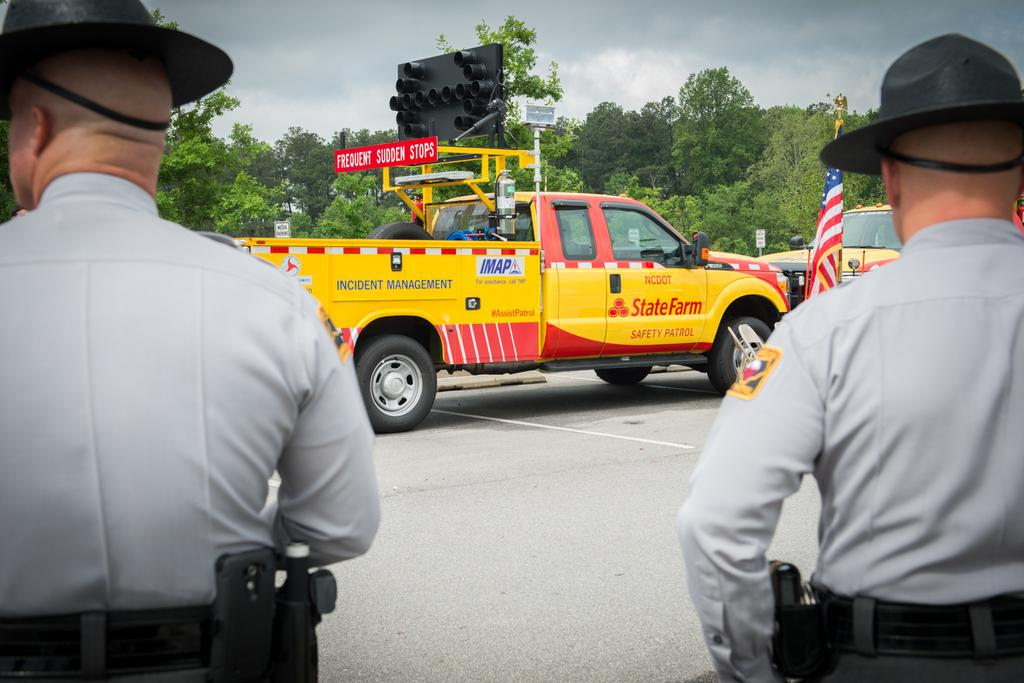How many people are in the image? There are 2 people in the image. What are the people wearing on their heads? The people are wearing hats. Where are the people standing in the image? The people are standing on the road. What types of vehicles can be seen on the road? There are yellow and red vehicles on the road. What is present near the road in the image? Trees are present near the road. How would you describe the sky in the image? The sky is cloudy. What type of trick can be seen being performed by the ducks in the image? There are no ducks present in the image, so no trick can be observed. Is there any gold visible in the image? There is no gold present in the image. 